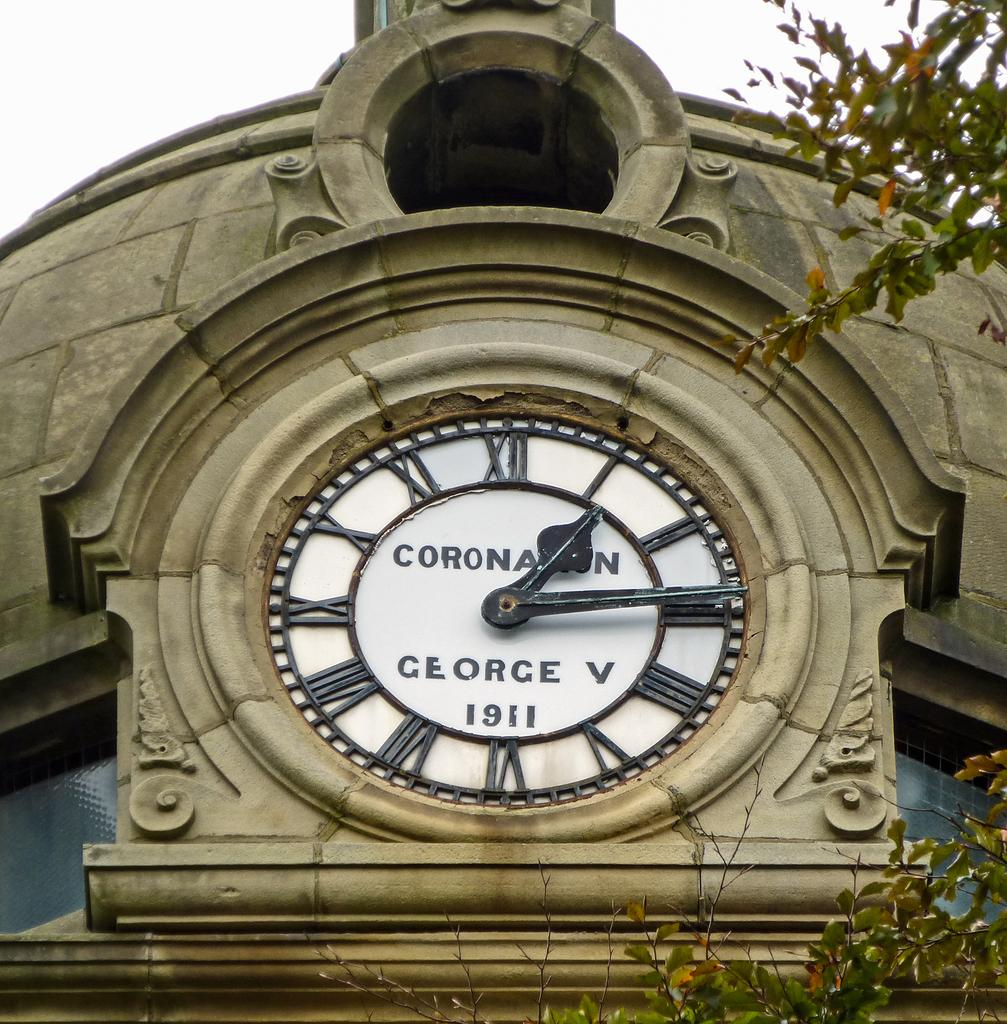<image>
Provide a brief description of the given image. A stone building has a clock built into it that says Coronan George V 1911. 